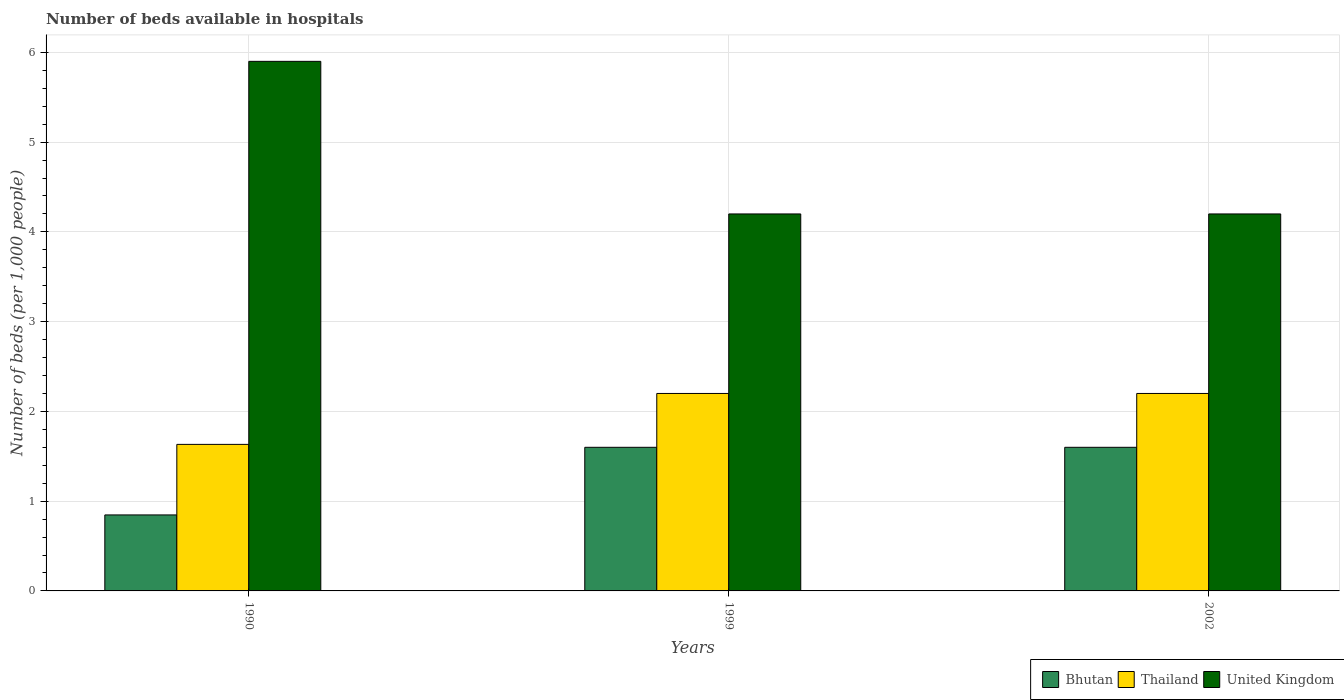How many different coloured bars are there?
Ensure brevity in your answer.  3. How many groups of bars are there?
Provide a succinct answer. 3. Are the number of bars on each tick of the X-axis equal?
Offer a terse response. Yes. How many bars are there on the 1st tick from the left?
Provide a short and direct response. 3. What is the number of beds in the hospiatls of in Thailand in 1990?
Your answer should be compact. 1.63. Across all years, what is the maximum number of beds in the hospiatls of in United Kingdom?
Give a very brief answer. 5.9. Across all years, what is the minimum number of beds in the hospiatls of in Thailand?
Keep it short and to the point. 1.63. In which year was the number of beds in the hospiatls of in United Kingdom maximum?
Offer a very short reply. 1990. In which year was the number of beds in the hospiatls of in Thailand minimum?
Give a very brief answer. 1990. What is the total number of beds in the hospiatls of in Thailand in the graph?
Ensure brevity in your answer.  6.03. What is the difference between the number of beds in the hospiatls of in Thailand in 1990 and that in 1999?
Your answer should be compact. -0.57. What is the difference between the number of beds in the hospiatls of in Thailand in 2002 and the number of beds in the hospiatls of in United Kingdom in 1990?
Provide a short and direct response. -3.7. What is the average number of beds in the hospiatls of in Bhutan per year?
Provide a succinct answer. 1.35. In the year 1999, what is the difference between the number of beds in the hospiatls of in United Kingdom and number of beds in the hospiatls of in Thailand?
Provide a succinct answer. 2. What is the ratio of the number of beds in the hospiatls of in Thailand in 1999 to that in 2002?
Provide a succinct answer. 1. Is the difference between the number of beds in the hospiatls of in United Kingdom in 1990 and 2002 greater than the difference between the number of beds in the hospiatls of in Thailand in 1990 and 2002?
Make the answer very short. Yes. What is the difference between the highest and the second highest number of beds in the hospiatls of in Bhutan?
Make the answer very short. 2.3799999970819385e-8. What is the difference between the highest and the lowest number of beds in the hospiatls of in Bhutan?
Provide a short and direct response. 0.75. In how many years, is the number of beds in the hospiatls of in United Kingdom greater than the average number of beds in the hospiatls of in United Kingdom taken over all years?
Ensure brevity in your answer.  1. What does the 3rd bar from the left in 1990 represents?
Provide a succinct answer. United Kingdom. What does the 3rd bar from the right in 2002 represents?
Make the answer very short. Bhutan. Are all the bars in the graph horizontal?
Ensure brevity in your answer.  No. How many years are there in the graph?
Keep it short and to the point. 3. Does the graph contain grids?
Your response must be concise. Yes. Where does the legend appear in the graph?
Your answer should be compact. Bottom right. How are the legend labels stacked?
Your answer should be compact. Horizontal. What is the title of the graph?
Offer a terse response. Number of beds available in hospitals. Does "Kuwait" appear as one of the legend labels in the graph?
Your answer should be compact. No. What is the label or title of the X-axis?
Your answer should be compact. Years. What is the label or title of the Y-axis?
Make the answer very short. Number of beds (per 1,0 people). What is the Number of beds (per 1,000 people) of Bhutan in 1990?
Keep it short and to the point. 0.85. What is the Number of beds (per 1,000 people) of Thailand in 1990?
Give a very brief answer. 1.63. What is the Number of beds (per 1,000 people) of United Kingdom in 1990?
Offer a very short reply. 5.9. What is the Number of beds (per 1,000 people) of Bhutan in 1999?
Your answer should be compact. 1.6. What is the Number of beds (per 1,000 people) in Thailand in 1999?
Make the answer very short. 2.2. What is the Number of beds (per 1,000 people) of United Kingdom in 1999?
Keep it short and to the point. 4.2. What is the Number of beds (per 1,000 people) in Bhutan in 2002?
Offer a very short reply. 1.6. What is the Number of beds (per 1,000 people) in Thailand in 2002?
Offer a terse response. 2.2. What is the Number of beds (per 1,000 people) in United Kingdom in 2002?
Offer a terse response. 4.2. Across all years, what is the maximum Number of beds (per 1,000 people) of Bhutan?
Your answer should be very brief. 1.6. Across all years, what is the maximum Number of beds (per 1,000 people) of Thailand?
Provide a succinct answer. 2.2. Across all years, what is the maximum Number of beds (per 1,000 people) of United Kingdom?
Your response must be concise. 5.9. Across all years, what is the minimum Number of beds (per 1,000 people) in Bhutan?
Your answer should be very brief. 0.85. Across all years, what is the minimum Number of beds (per 1,000 people) in Thailand?
Make the answer very short. 1.63. Across all years, what is the minimum Number of beds (per 1,000 people) of United Kingdom?
Ensure brevity in your answer.  4.2. What is the total Number of beds (per 1,000 people) of Bhutan in the graph?
Offer a very short reply. 4.05. What is the total Number of beds (per 1,000 people) in Thailand in the graph?
Your response must be concise. 6.03. What is the difference between the Number of beds (per 1,000 people) in Bhutan in 1990 and that in 1999?
Make the answer very short. -0.75. What is the difference between the Number of beds (per 1,000 people) in Thailand in 1990 and that in 1999?
Ensure brevity in your answer.  -0.57. What is the difference between the Number of beds (per 1,000 people) of United Kingdom in 1990 and that in 1999?
Provide a succinct answer. 1.7. What is the difference between the Number of beds (per 1,000 people) of Bhutan in 1990 and that in 2002?
Give a very brief answer. -0.75. What is the difference between the Number of beds (per 1,000 people) of Thailand in 1990 and that in 2002?
Give a very brief answer. -0.57. What is the difference between the Number of beds (per 1,000 people) of United Kingdom in 1990 and that in 2002?
Keep it short and to the point. 1.7. What is the difference between the Number of beds (per 1,000 people) of Bhutan in 1990 and the Number of beds (per 1,000 people) of Thailand in 1999?
Keep it short and to the point. -1.35. What is the difference between the Number of beds (per 1,000 people) of Bhutan in 1990 and the Number of beds (per 1,000 people) of United Kingdom in 1999?
Provide a short and direct response. -3.35. What is the difference between the Number of beds (per 1,000 people) of Thailand in 1990 and the Number of beds (per 1,000 people) of United Kingdom in 1999?
Your answer should be compact. -2.57. What is the difference between the Number of beds (per 1,000 people) in Bhutan in 1990 and the Number of beds (per 1,000 people) in Thailand in 2002?
Give a very brief answer. -1.35. What is the difference between the Number of beds (per 1,000 people) in Bhutan in 1990 and the Number of beds (per 1,000 people) in United Kingdom in 2002?
Provide a short and direct response. -3.35. What is the difference between the Number of beds (per 1,000 people) in Thailand in 1990 and the Number of beds (per 1,000 people) in United Kingdom in 2002?
Provide a succinct answer. -2.57. What is the difference between the Number of beds (per 1,000 people) in Bhutan in 1999 and the Number of beds (per 1,000 people) in Thailand in 2002?
Provide a succinct answer. -0.6. What is the difference between the Number of beds (per 1,000 people) in Bhutan in 1999 and the Number of beds (per 1,000 people) in United Kingdom in 2002?
Keep it short and to the point. -2.6. What is the average Number of beds (per 1,000 people) in Bhutan per year?
Make the answer very short. 1.35. What is the average Number of beds (per 1,000 people) in Thailand per year?
Your answer should be very brief. 2.01. What is the average Number of beds (per 1,000 people) in United Kingdom per year?
Offer a very short reply. 4.77. In the year 1990, what is the difference between the Number of beds (per 1,000 people) in Bhutan and Number of beds (per 1,000 people) in Thailand?
Ensure brevity in your answer.  -0.79. In the year 1990, what is the difference between the Number of beds (per 1,000 people) of Bhutan and Number of beds (per 1,000 people) of United Kingdom?
Keep it short and to the point. -5.05. In the year 1990, what is the difference between the Number of beds (per 1,000 people) of Thailand and Number of beds (per 1,000 people) of United Kingdom?
Give a very brief answer. -4.27. In the year 1999, what is the difference between the Number of beds (per 1,000 people) of Bhutan and Number of beds (per 1,000 people) of United Kingdom?
Offer a very short reply. -2.6. In the year 2002, what is the difference between the Number of beds (per 1,000 people) of Bhutan and Number of beds (per 1,000 people) of United Kingdom?
Your answer should be compact. -2.6. What is the ratio of the Number of beds (per 1,000 people) in Bhutan in 1990 to that in 1999?
Ensure brevity in your answer.  0.53. What is the ratio of the Number of beds (per 1,000 people) of Thailand in 1990 to that in 1999?
Provide a short and direct response. 0.74. What is the ratio of the Number of beds (per 1,000 people) in United Kingdom in 1990 to that in 1999?
Make the answer very short. 1.4. What is the ratio of the Number of beds (per 1,000 people) of Bhutan in 1990 to that in 2002?
Provide a short and direct response. 0.53. What is the ratio of the Number of beds (per 1,000 people) in Thailand in 1990 to that in 2002?
Your response must be concise. 0.74. What is the ratio of the Number of beds (per 1,000 people) in United Kingdom in 1990 to that in 2002?
Give a very brief answer. 1.4. What is the ratio of the Number of beds (per 1,000 people) of Bhutan in 1999 to that in 2002?
Give a very brief answer. 1. What is the ratio of the Number of beds (per 1,000 people) in Thailand in 1999 to that in 2002?
Provide a succinct answer. 1. What is the difference between the highest and the second highest Number of beds (per 1,000 people) of Bhutan?
Your answer should be compact. 0. What is the difference between the highest and the second highest Number of beds (per 1,000 people) of Thailand?
Offer a terse response. 0. What is the difference between the highest and the lowest Number of beds (per 1,000 people) of Bhutan?
Give a very brief answer. 0.75. What is the difference between the highest and the lowest Number of beds (per 1,000 people) of Thailand?
Offer a terse response. 0.57. What is the difference between the highest and the lowest Number of beds (per 1,000 people) of United Kingdom?
Your response must be concise. 1.7. 